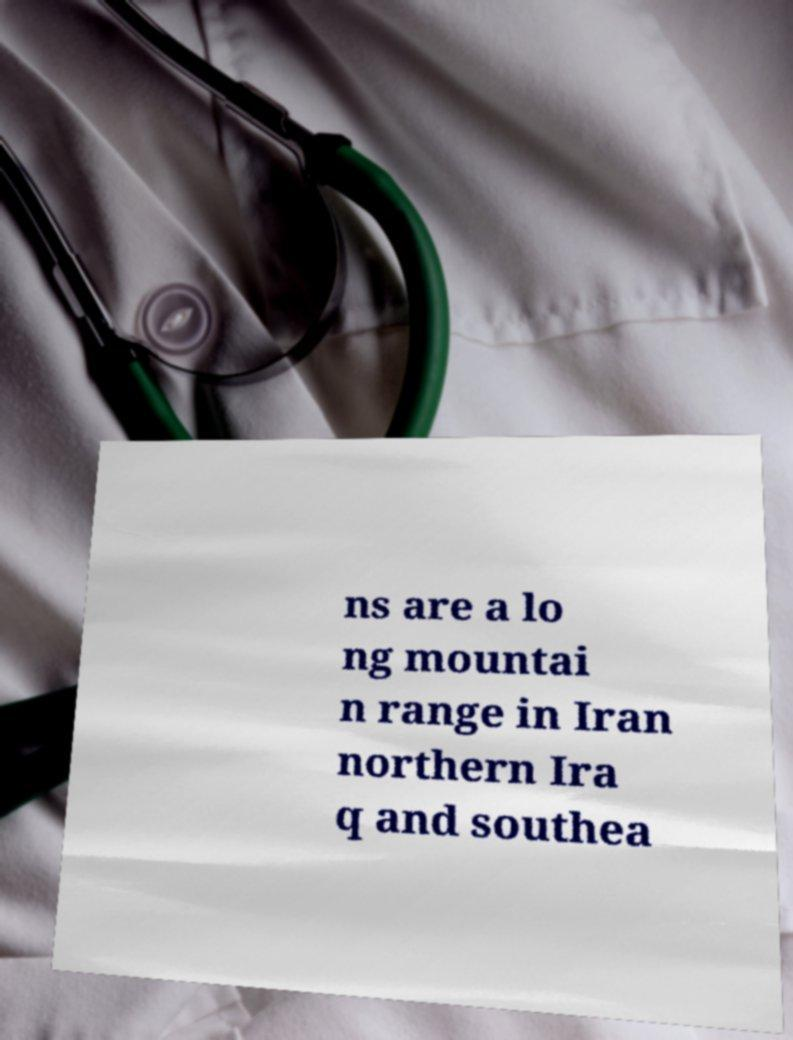For documentation purposes, I need the text within this image transcribed. Could you provide that? ns are a lo ng mountai n range in Iran northern Ira q and southea 